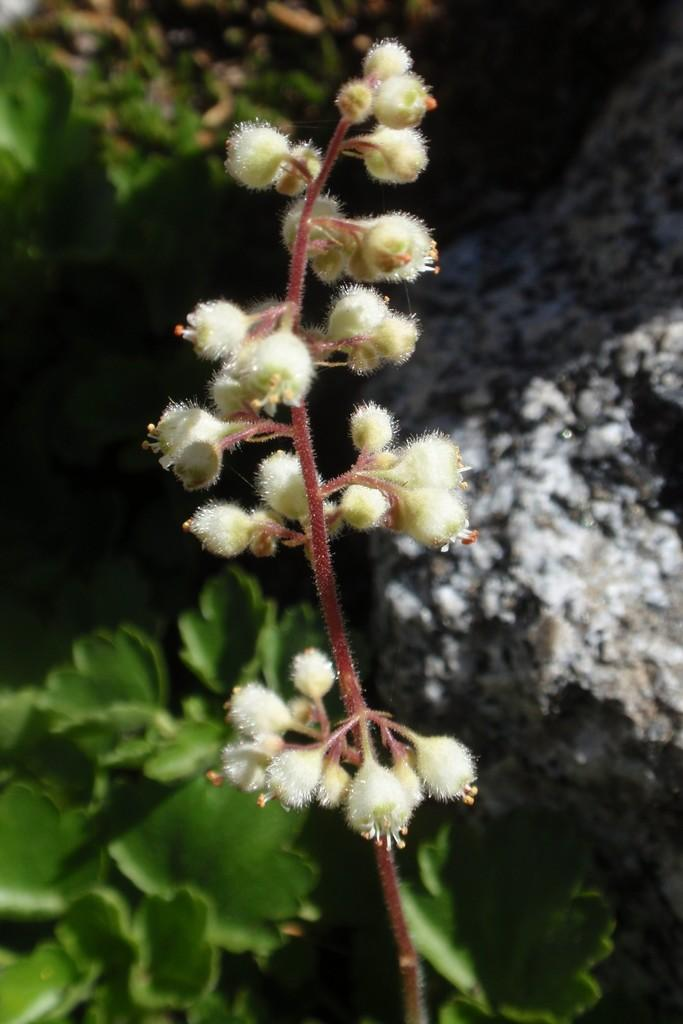What is present in the image? There is a plant with flowers in the image. Are there any other plants visible in the image? Yes, there is another plant at the bottom of the image. How many geese are grazing near the plants in the image? There are no geese present in the image; it only features plants. Is there a farmer tending to the plants in the image? There is no farmer present in the image; it only features plants. 